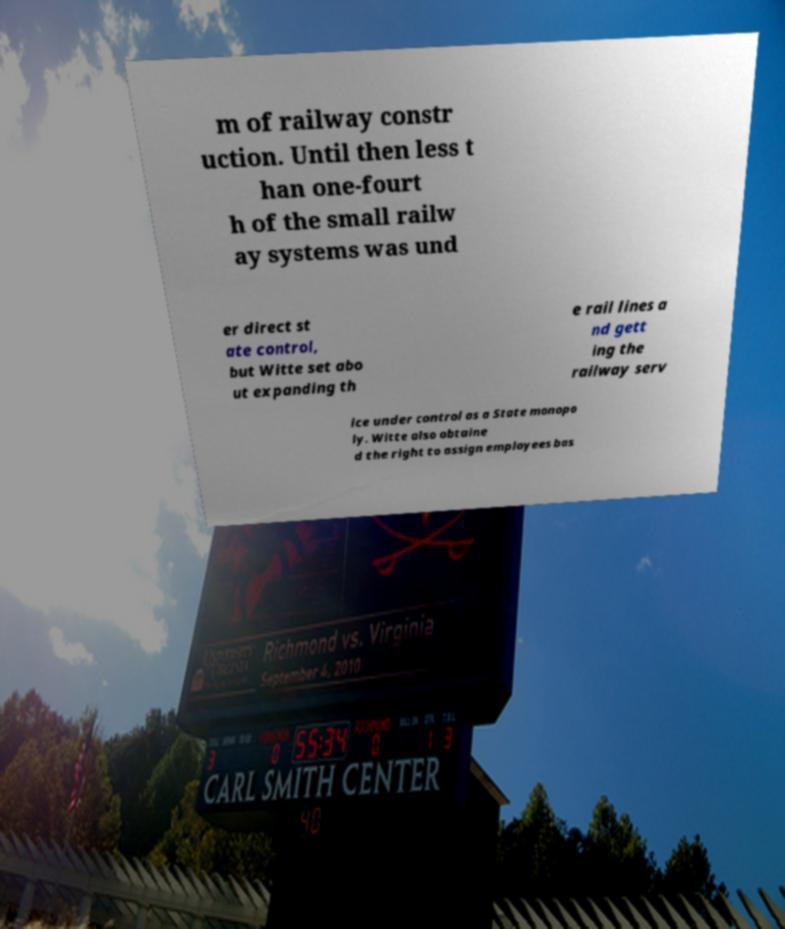Can you read and provide the text displayed in the image?This photo seems to have some interesting text. Can you extract and type it out for me? m of railway constr uction. Until then less t han one-fourt h of the small railw ay systems was und er direct st ate control, but Witte set abo ut expanding th e rail lines a nd gett ing the railway serv ice under control as a State monopo ly. Witte also obtaine d the right to assign employees bas 